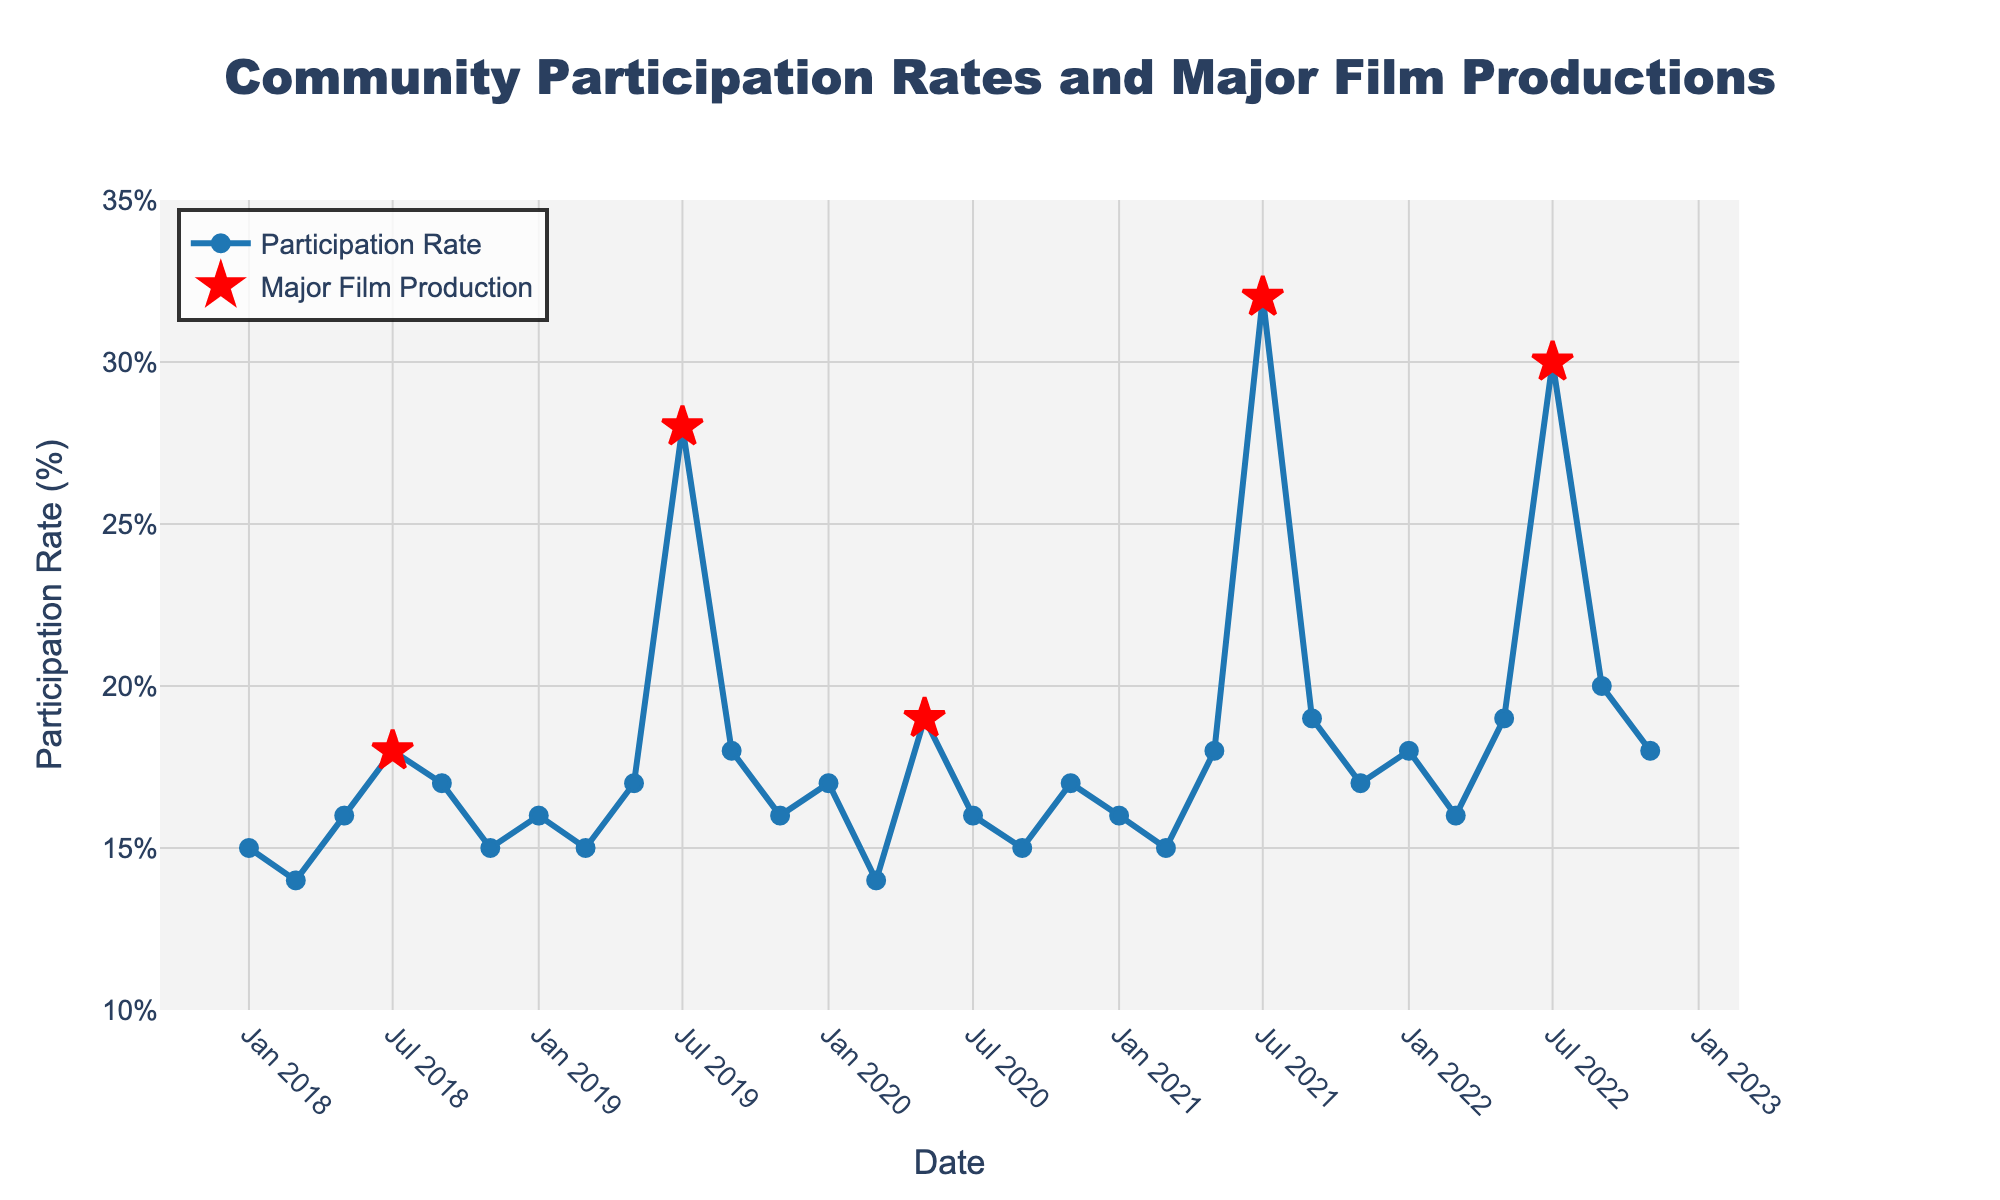What's the highest participation rate observed in the chart? The highest participation rate can be identified visually by finding the peak point on the line chart.
Answer: 32% How many times does the participation rate spike due to major film productions? By observing the red star markers on the plot, which denote major film productions, count these markers.
Answer: 5 What's the participation rate in July 2019 and how does it compare to the month before? Find the data point for July 2019 and the data point for the previous month on the line chart. Compare these values (July 2019: 28%, previous month May 2019: 17%).
Answer: Higher by 11% What is the average participation rate excluding the months with major film productions? Sum the participation rates for months without major film productions and divide by the number of such months. ((15+14+16+17+15+16+15+18+16+15+17+16+15+18+19+16+17+18+16)/22)
Answer: 16.59% During which major film production did the participation rate see the highest increase compared to the previous month? Calculate the difference for each spike due to major film production and identify the maximum increase. (2021, July: Increase of 14%)
Answer: July 2021 Which year had the highest overall average participation rate? Calculate the average participation rate for each year. (2018: 15.8%, 2019: 18.33%, 2020: 16.33%, 2021: 18.5%, 2022: 17.83%)
Answer: 2021 How does the participation rate in July 2022 compare to its value in July 2018? Find the values for July 2022 and July 2018, then compare them (July 2022: 30%, July 2018: 18%).
Answer: Increase by 12% Analyze the trend of participation rates across the years and identify any patterns in relation to film productions. Observe general trends such as increases or decreases, noting significant changes during film productions.
Answer: Spike during film productions What is the smallest gap in participation rates between two consecutive data points? Calculate the differences between each consecutive data point and identify the smallest gap. (Smallest difference occurs between Sept 2020 and Nov 2020: 1%)
Answer: 1% What's the most frequent participation rate observed on the plot? Identify the participation rates and count their occurrences to find the most frequent one. (Participation rates of 15% and 16% each occur 5 times)
Answer: 15% and 16% (tie) 